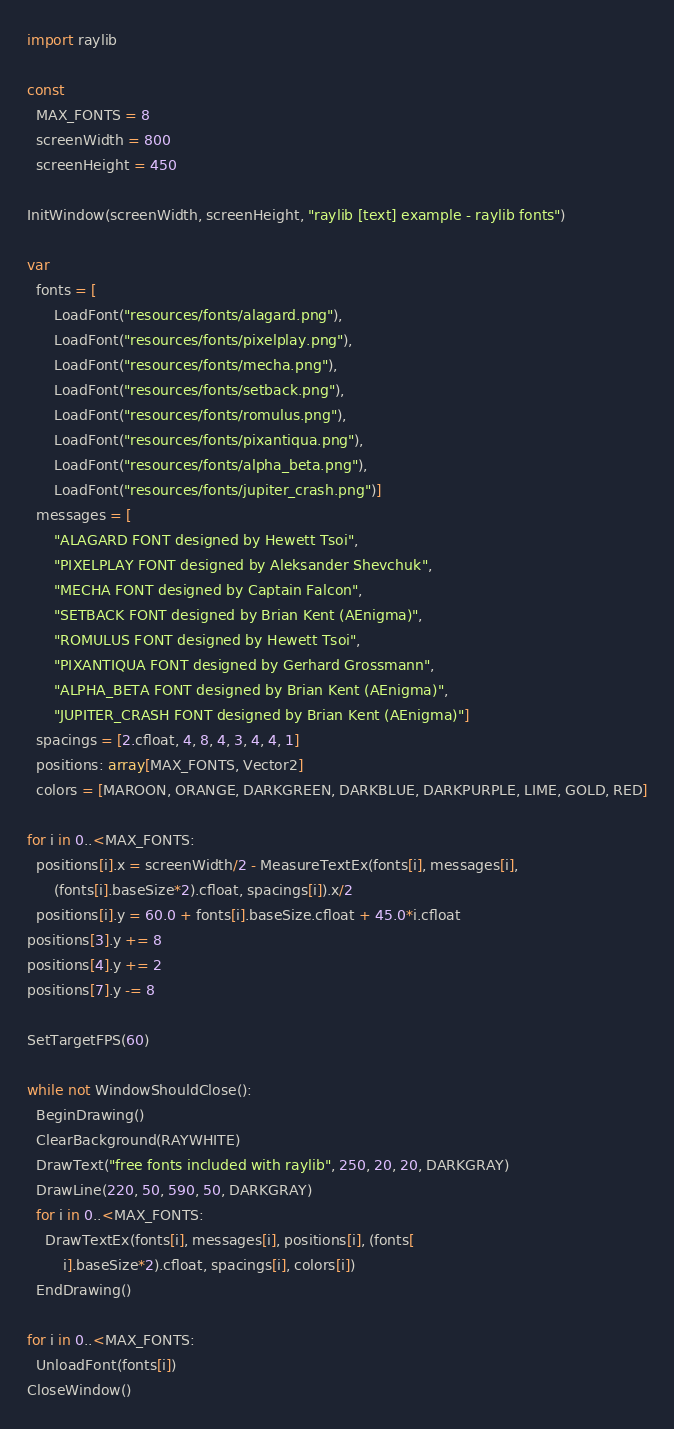<code> <loc_0><loc_0><loc_500><loc_500><_Nim_>import raylib

const
  MAX_FONTS = 8
  screenWidth = 800
  screenHeight = 450

InitWindow(screenWidth, screenHeight, "raylib [text] example - raylib fonts")

var
  fonts = [
      LoadFont("resources/fonts/alagard.png"),
      LoadFont("resources/fonts/pixelplay.png"),
      LoadFont("resources/fonts/mecha.png"),
      LoadFont("resources/fonts/setback.png"),
      LoadFont("resources/fonts/romulus.png"),
      LoadFont("resources/fonts/pixantiqua.png"),
      LoadFont("resources/fonts/alpha_beta.png"),
      LoadFont("resources/fonts/jupiter_crash.png")]
  messages = [
      "ALAGARD FONT designed by Hewett Tsoi",
      "PIXELPLAY FONT designed by Aleksander Shevchuk",
      "MECHA FONT designed by Captain Falcon",
      "SETBACK FONT designed by Brian Kent (AEnigma)",
      "ROMULUS FONT designed by Hewett Tsoi",
      "PIXANTIQUA FONT designed by Gerhard Grossmann",
      "ALPHA_BETA FONT designed by Brian Kent (AEnigma)",
      "JUPITER_CRASH FONT designed by Brian Kent (AEnigma)"]
  spacings = [2.cfloat, 4, 8, 4, 3, 4, 4, 1]
  positions: array[MAX_FONTS, Vector2]
  colors = [MAROON, ORANGE, DARKGREEN, DARKBLUE, DARKPURPLE, LIME, GOLD, RED]

for i in 0..<MAX_FONTS:
  positions[i].x = screenWidth/2 - MeasureTextEx(fonts[i], messages[i],
      (fonts[i].baseSize*2).cfloat, spacings[i]).x/2
  positions[i].y = 60.0 + fonts[i].baseSize.cfloat + 45.0*i.cfloat
positions[3].y += 8
positions[4].y += 2
positions[7].y -= 8

SetTargetFPS(60)

while not WindowShouldClose():
  BeginDrawing()
  ClearBackground(RAYWHITE)
  DrawText("free fonts included with raylib", 250, 20, 20, DARKGRAY)
  DrawLine(220, 50, 590, 50, DARKGRAY)
  for i in 0..<MAX_FONTS:
    DrawTextEx(fonts[i], messages[i], positions[i], (fonts[
        i].baseSize*2).cfloat, spacings[i], colors[i])
  EndDrawing()

for i in 0..<MAX_FONTS:
  UnloadFont(fonts[i])
CloseWindow()
</code> 